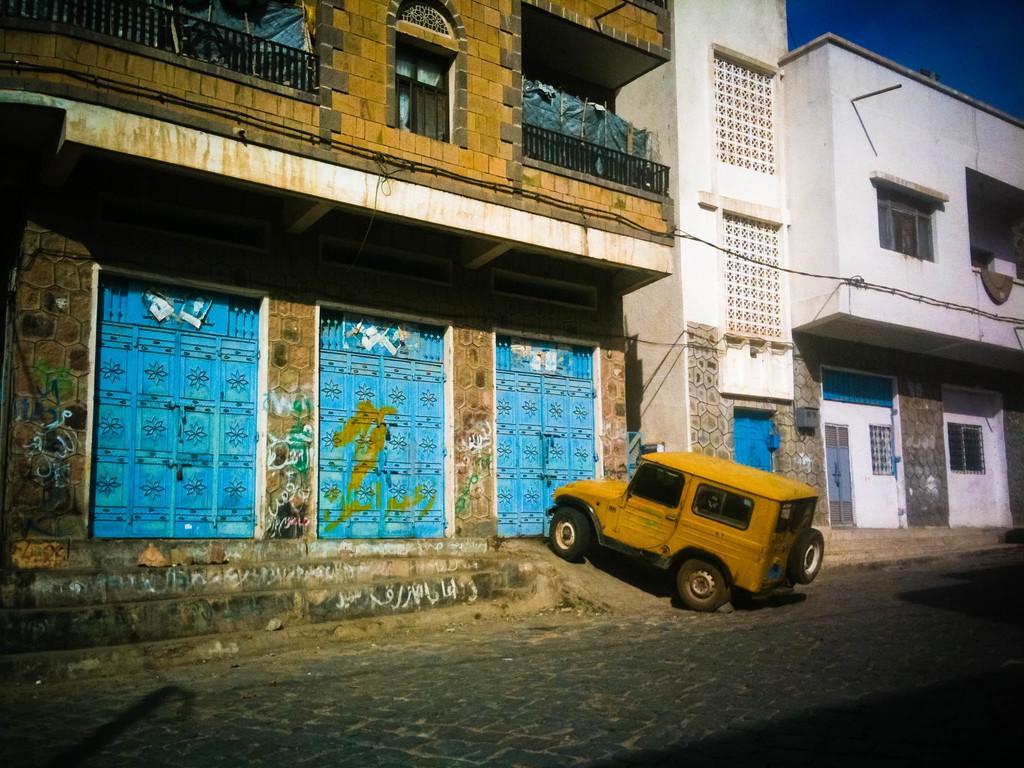Please provide a concise description of this image. This image is taken outdoors. At the bottom of the image there is a road. In the middle of the image there are two buildings with walls, windows, doors, railings and balconies. A jeep is parked on the road. 